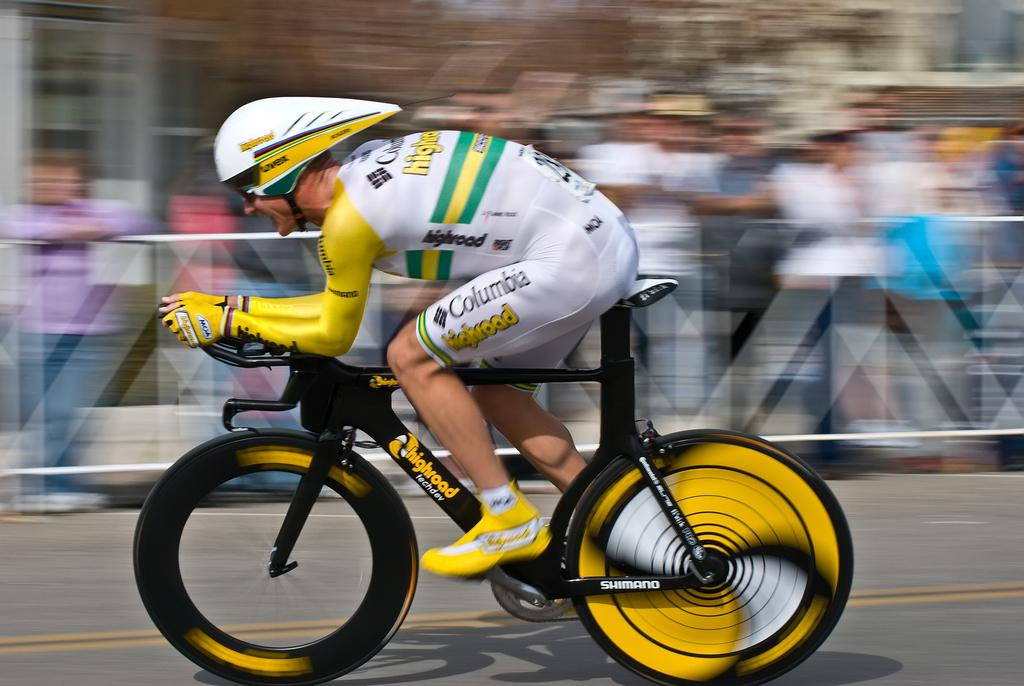What is the person in the image doing? The person is riding a bicycle in the image. Can you describe the bicycle? The bicycle is yellow and black. What safety precaution is the person taking while riding the bicycle? The person is wearing a helmet. What is the person wearing on their body? The person is wearing a white and yellow dress. How would you describe the background of the image? The background of the image is blurred. What type of organization is hosting the eggnog party in the image? There is no eggnog party or organization present in the image; it features a person riding a yellow and black bicycle. Can you tell me how many swings are visible in the playground in the image? There is no playground present in the image; it features a person riding a bicycle in a blurred background. 